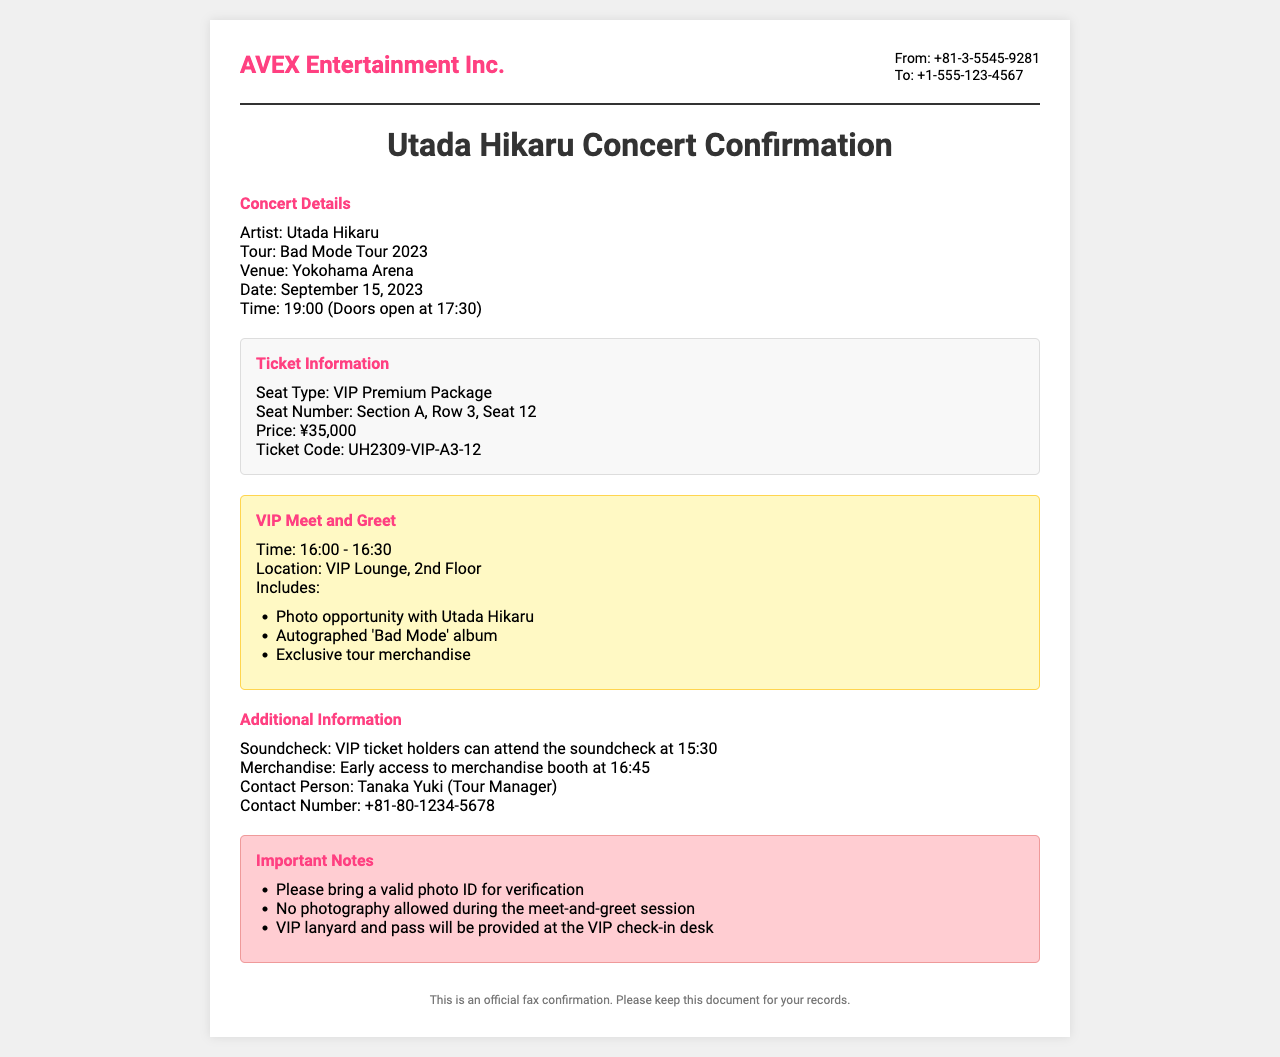What is the artist's name? The artist performing at the concert is mentioned at the beginning of the document.
Answer: Utada Hikaru What is the venue for the concert? The venue is specified in the concert details section of the document.
Answer: Yokohama Arena What time does the concert begin? The starting time is provided in the concert details section, listing when the concert will start.
Answer: 19:00 What is the price of the VIP Premium Package? The price is clearly stated in the ticket information section of the document.
Answer: ¥35,000 What is included in the VIP meet-and-greet? The document lists specific items and experiences included in the VIP meet-and-greet area.
Answer: Photo opportunity, autographed album, exclusive merchandise What time can VIP ticket holders attend the soundcheck? The time for the soundcheck is explicitly mentioned in the additional information section.
Answer: 15:30 Who is the contact person for the concert? The contact person is listed in the additional information section of the document.
Answer: Tanaka Yuki What important note is mentioned regarding photography? An important note regarding photography is emphasized in the important notes section.
Answer: No photography allowed during the meet-and-greet session What is the relationship of the fax numbers provided? The fax numbers represent the sender and recipient, which is common in fax documents.
Answer: From and To contacts 